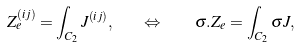<formula> <loc_0><loc_0><loc_500><loc_500>Z _ { e } ^ { \left ( i j \right ) } = \int _ { C _ { 2 } } J ^ { \left ( i j \right ) } , \quad \Leftrightarrow \quad \sigma . Z _ { e } = \int _ { C _ { 2 } } \sigma J ,</formula> 